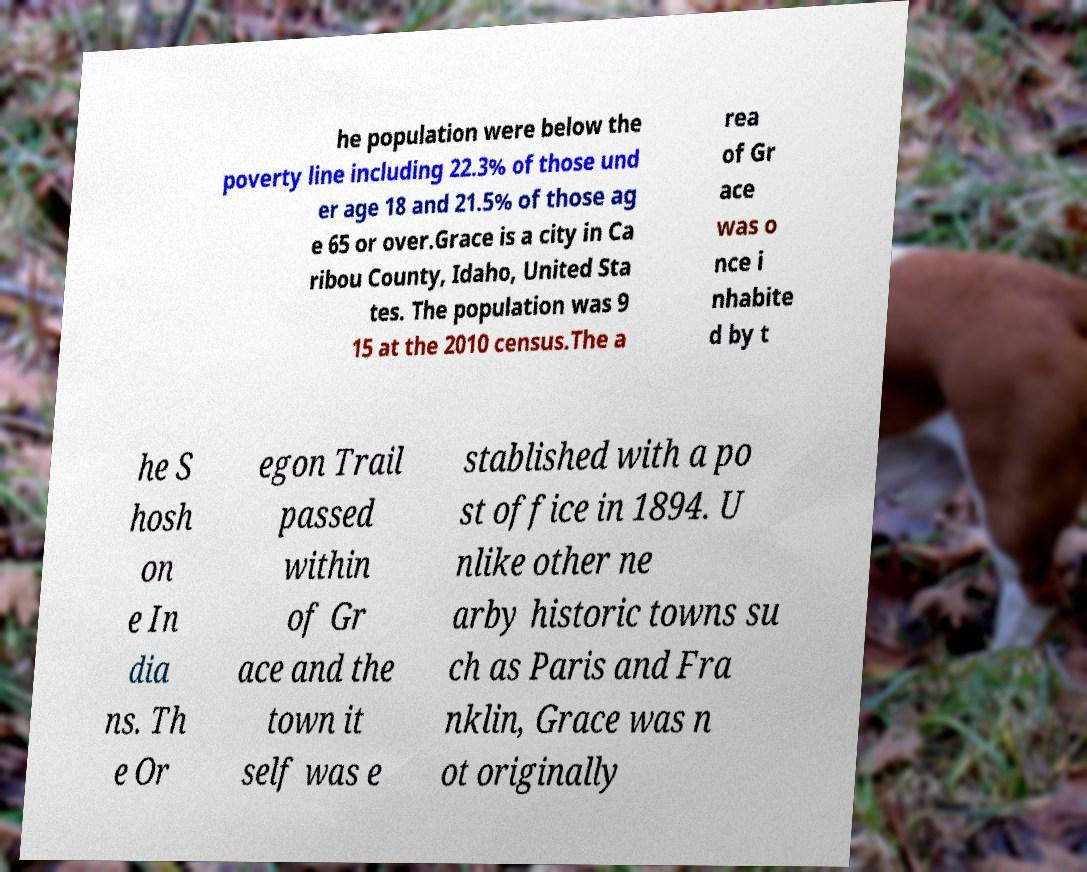Can you read and provide the text displayed in the image?This photo seems to have some interesting text. Can you extract and type it out for me? he population were below the poverty line including 22.3% of those und er age 18 and 21.5% of those ag e 65 or over.Grace is a city in Ca ribou County, Idaho, United Sta tes. The population was 9 15 at the 2010 census.The a rea of Gr ace was o nce i nhabite d by t he S hosh on e In dia ns. Th e Or egon Trail passed within of Gr ace and the town it self was e stablished with a po st office in 1894. U nlike other ne arby historic towns su ch as Paris and Fra nklin, Grace was n ot originally 